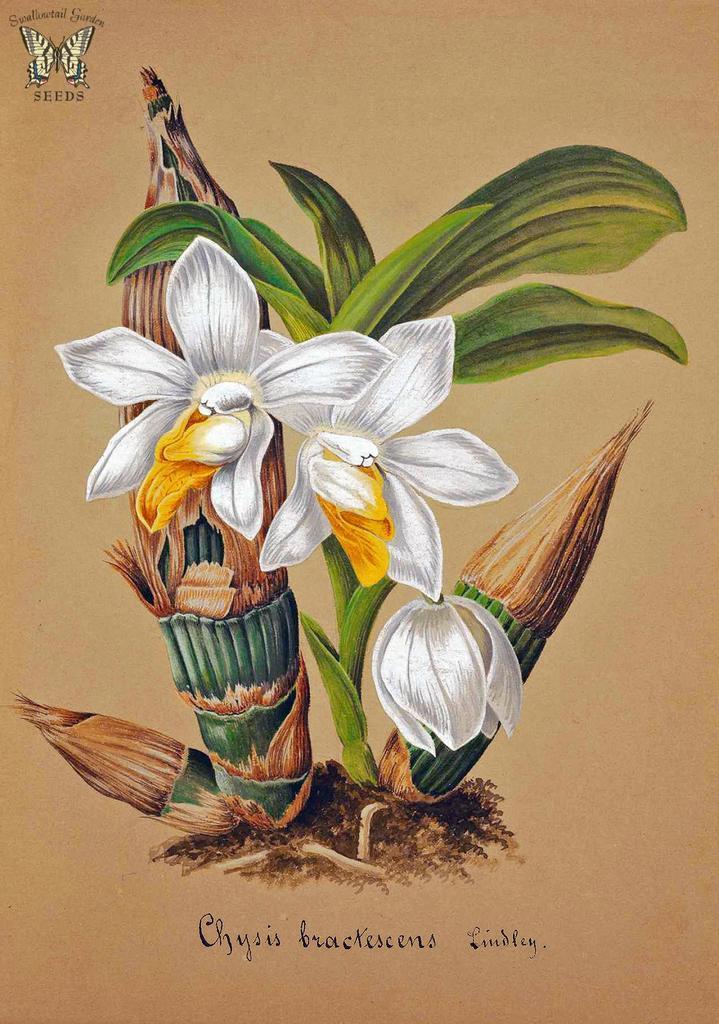Describe this image in one or two sentences. In this picture we can see a few white flowers and green leaves on the plants. We can see some text at the bottom of the picture. There is an image of a butterfly and some text in the bottom left. 